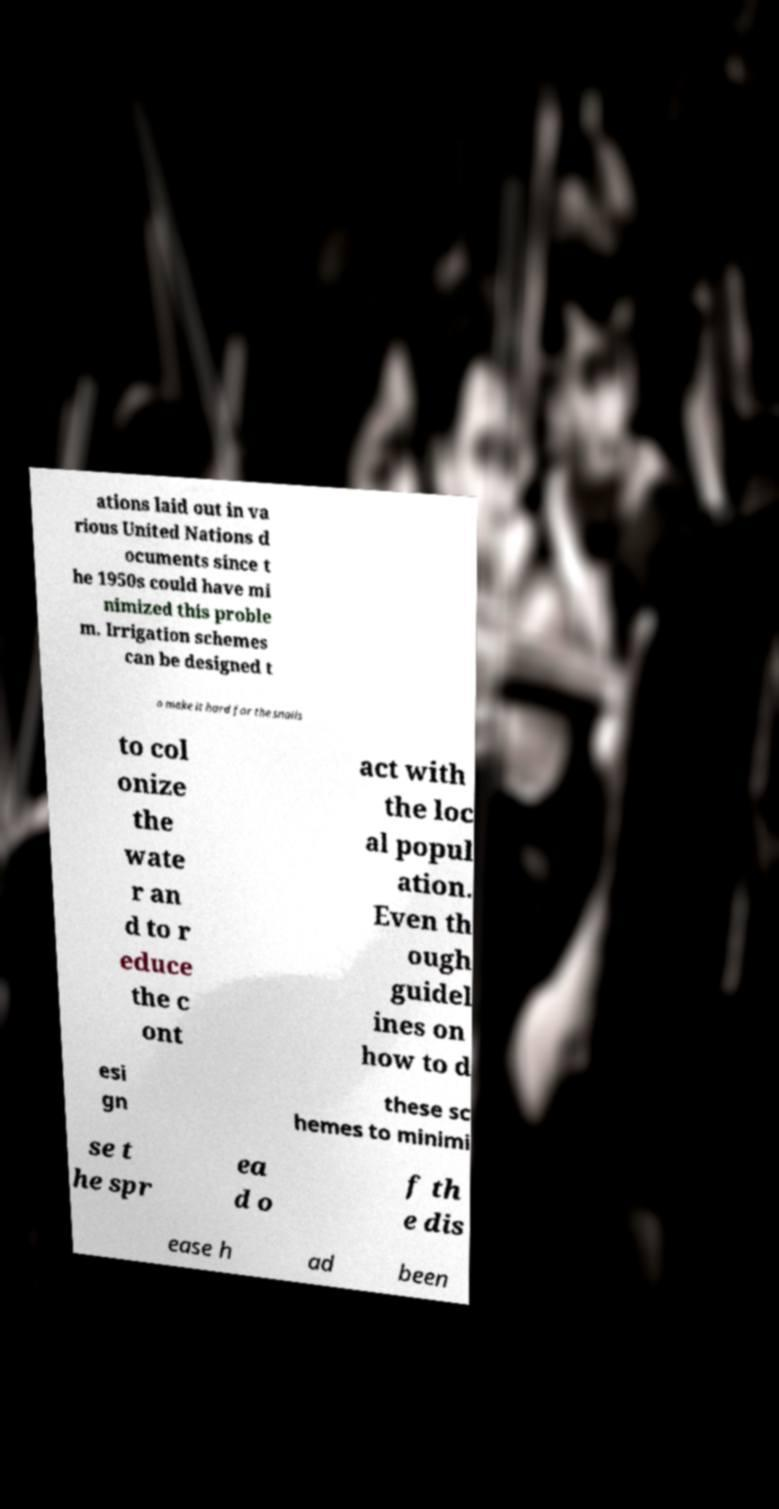I need the written content from this picture converted into text. Can you do that? ations laid out in va rious United Nations d ocuments since t he 1950s could have mi nimized this proble m. Irrigation schemes can be designed t o make it hard for the snails to col onize the wate r an d to r educe the c ont act with the loc al popul ation. Even th ough guidel ines on how to d esi gn these sc hemes to minimi se t he spr ea d o f th e dis ease h ad been 